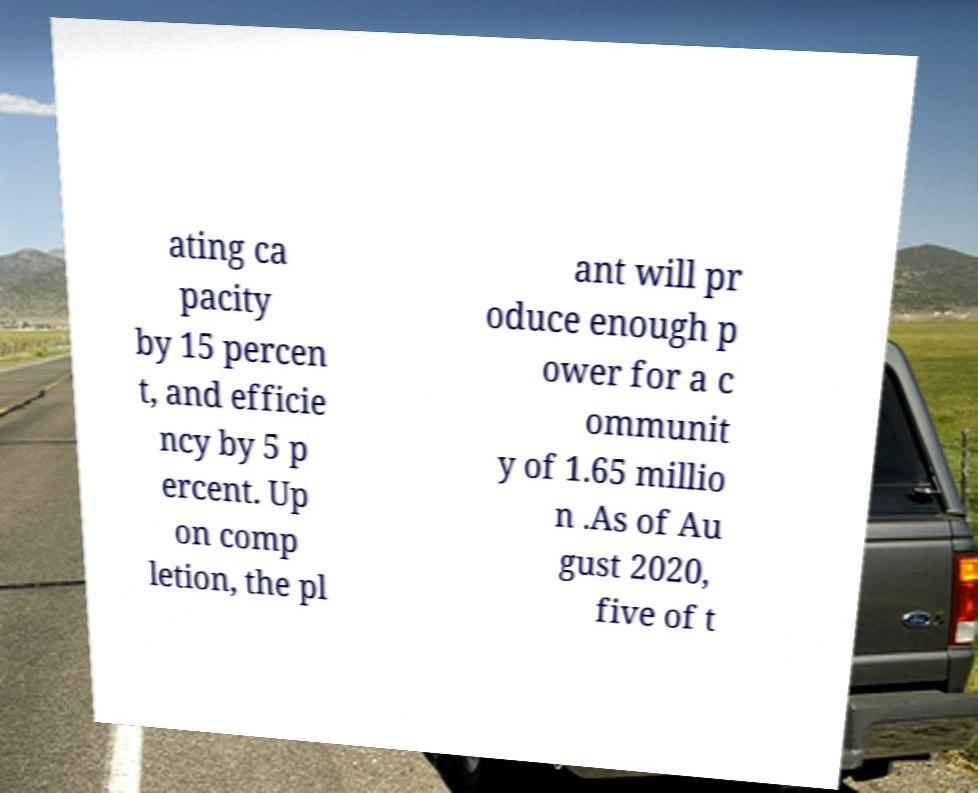There's text embedded in this image that I need extracted. Can you transcribe it verbatim? ating ca pacity by 15 percen t, and efficie ncy by 5 p ercent. Up on comp letion, the pl ant will pr oduce enough p ower for a c ommunit y of 1.65 millio n .As of Au gust 2020, five of t 